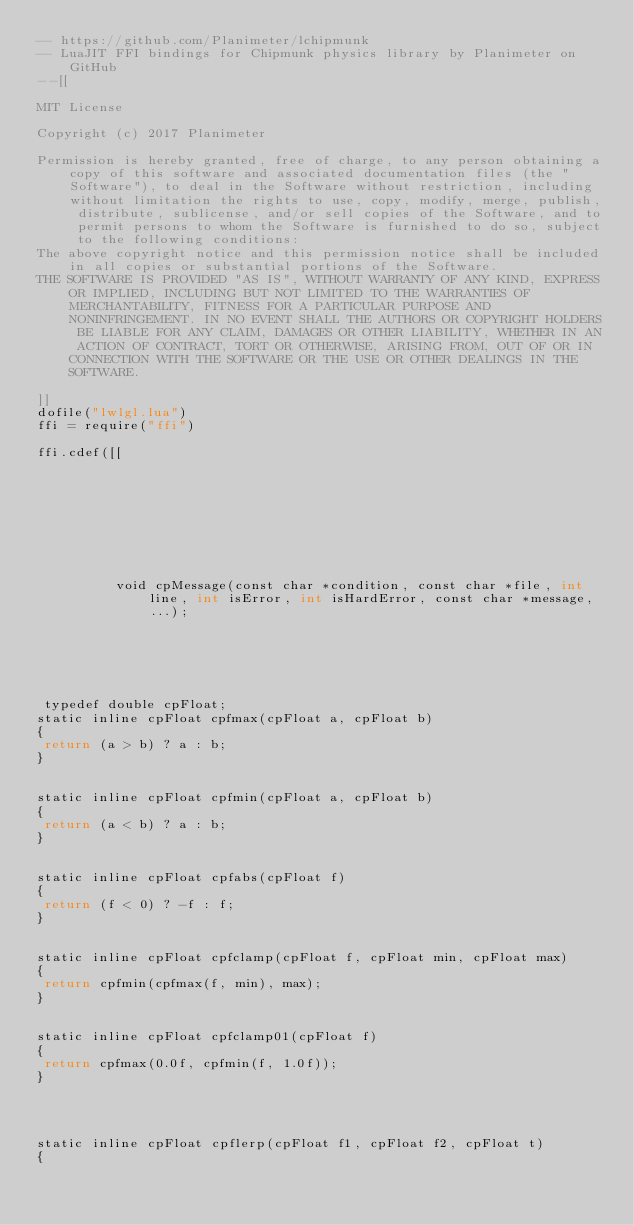<code> <loc_0><loc_0><loc_500><loc_500><_Lua_>-- https://github.com/Planimeter/lchipmunk
-- LuaJIT FFI bindings for Chipmunk physics library by Planimeter on GitHub
--[[

MIT License

Copyright (c) 2017 Planimeter

Permission is hereby granted, free of charge, to any person obtaining a copy of this software and associated documentation files (the "Software"), to deal in the Software without restriction, including without limitation the rights to use, copy, modify, merge, publish, distribute, sublicense, and/or sell copies of the Software, and to permit persons to whom the Software is furnished to do so, subject to the following conditions:
The above copyright notice and this permission notice shall be included in all copies or substantial portions of the Software.
THE SOFTWARE IS PROVIDED "AS IS", WITHOUT WARRANTY OF ANY KIND, EXPRESS OR IMPLIED, INCLUDING BUT NOT LIMITED TO THE WARRANTIES OF MERCHANTABILITY, FITNESS FOR A PARTICULAR PURPOSE AND NONINFRINGEMENT. IN NO EVENT SHALL THE AUTHORS OR COPYRIGHT HOLDERS BE LIABLE FOR ANY CLAIM, DAMAGES OR OTHER LIABILITY, WHETHER IN AN ACTION OF CONTRACT, TORT OR OTHERWISE, ARISING FROM, OUT OF OR IN CONNECTION WITH THE SOFTWARE OR THE USE OR OTHER DEALINGS IN THE SOFTWARE.

]]
dofile("lwlgl.lua")
ffi = require("ffi")

ffi.cdef([[









          void cpMessage(const char *condition, const char *file, int line, int isError, int isHardError, const char *message, ...);






 typedef double cpFloat;
static inline cpFloat cpfmax(cpFloat a, cpFloat b)
{
 return (a > b) ? a : b;
}


static inline cpFloat cpfmin(cpFloat a, cpFloat b)
{
 return (a < b) ? a : b;
}


static inline cpFloat cpfabs(cpFloat f)
{
 return (f < 0) ? -f : f;
}


static inline cpFloat cpfclamp(cpFloat f, cpFloat min, cpFloat max)
{
 return cpfmin(cpfmax(f, min), max);
}


static inline cpFloat cpfclamp01(cpFloat f)
{
 return cpfmax(0.0f, cpfmin(f, 1.0f));
}




static inline cpFloat cpflerp(cpFloat f1, cpFloat f2, cpFloat t)
{</code> 